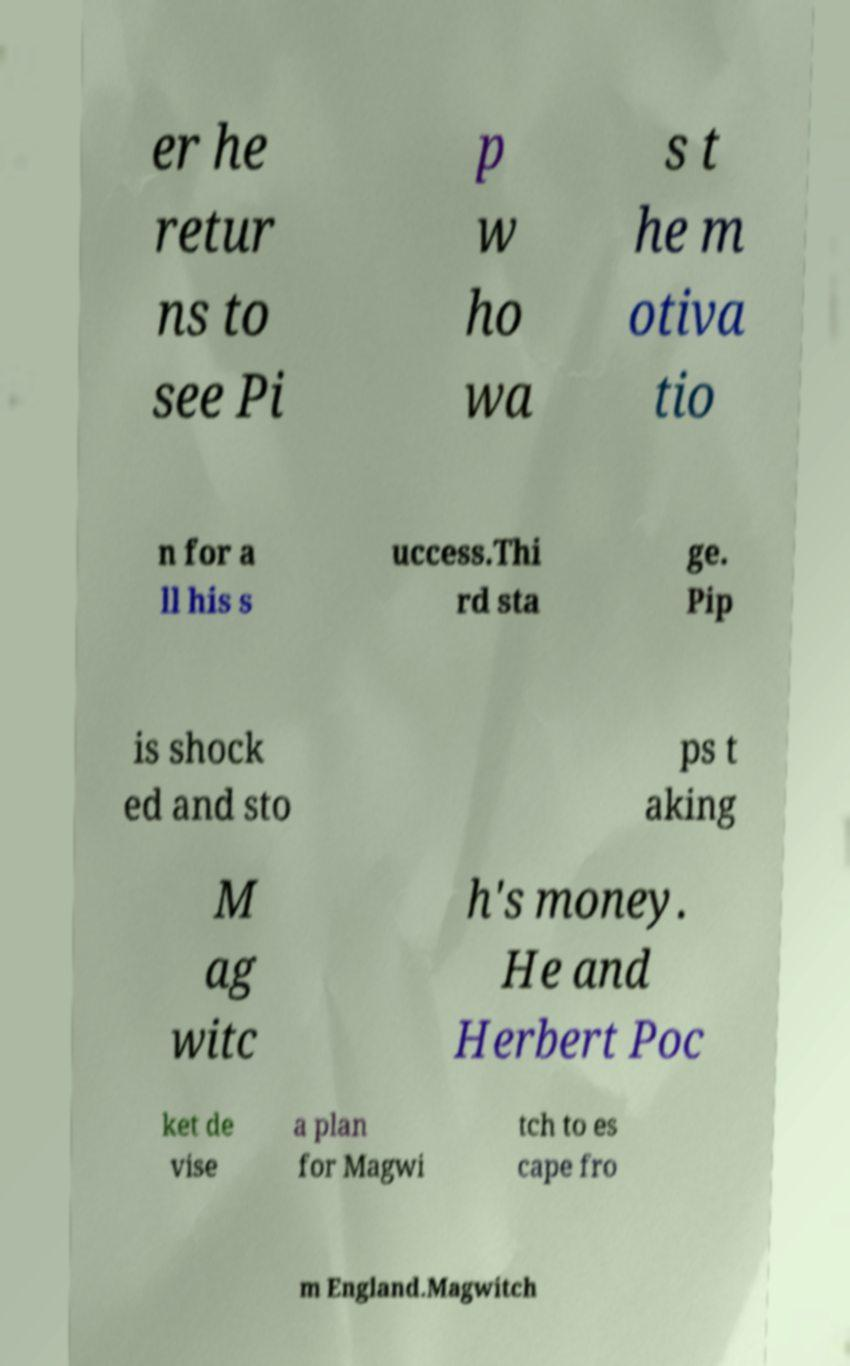Please read and relay the text visible in this image. What does it say? er he retur ns to see Pi p w ho wa s t he m otiva tio n for a ll his s uccess.Thi rd sta ge. Pip is shock ed and sto ps t aking M ag witc h's money. He and Herbert Poc ket de vise a plan for Magwi tch to es cape fro m England.Magwitch 